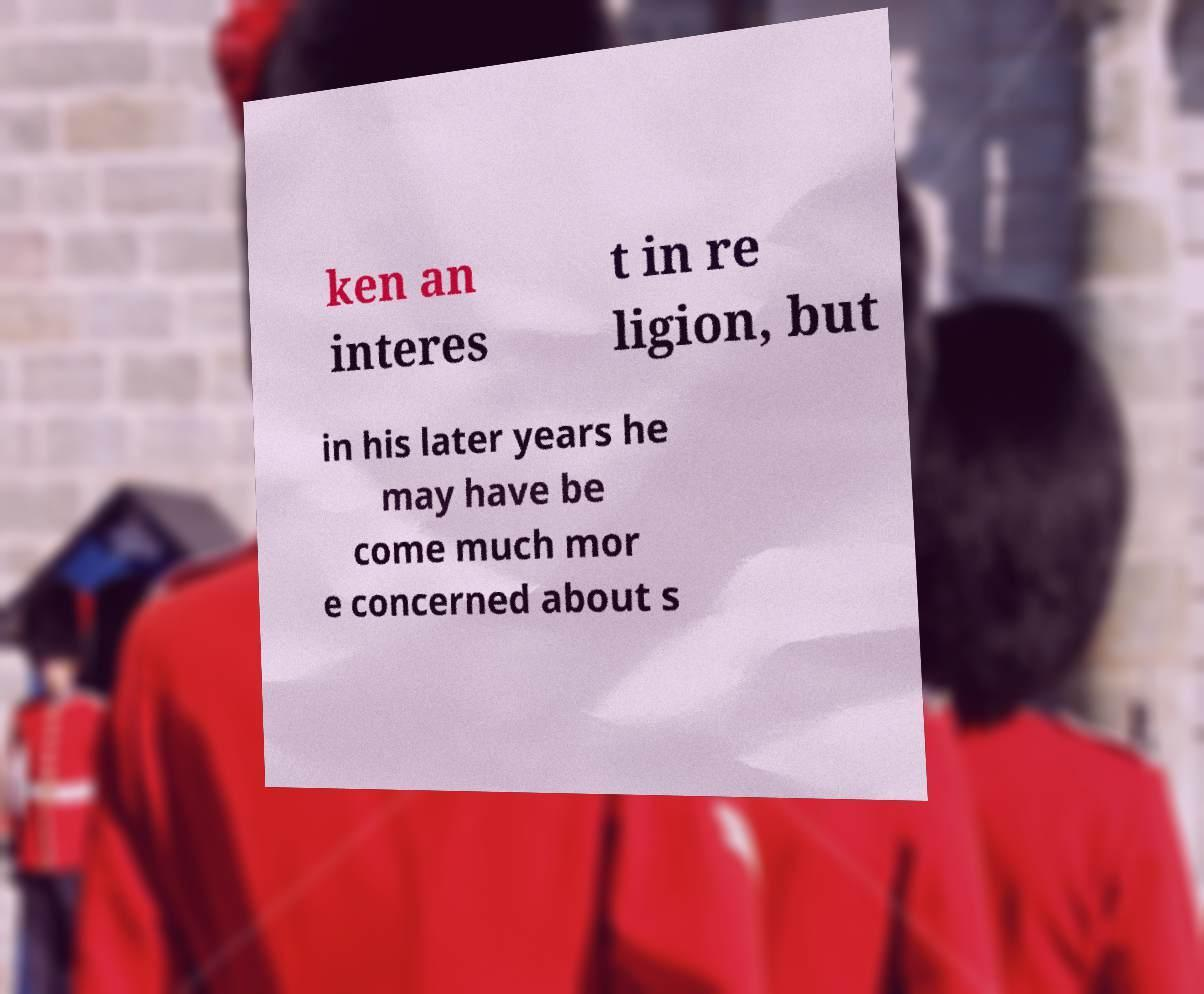Can you read and provide the text displayed in the image?This photo seems to have some interesting text. Can you extract and type it out for me? ken an interes t in re ligion, but in his later years he may have be come much mor e concerned about s 